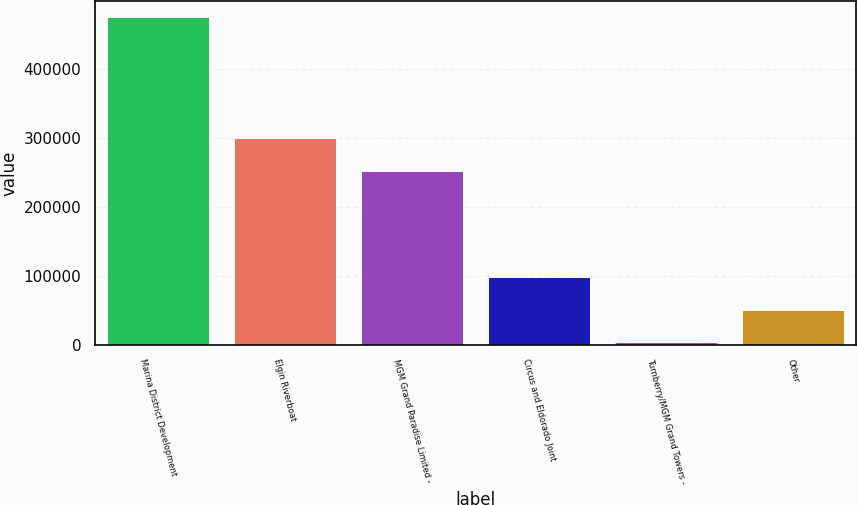Convert chart to OTSL. <chart><loc_0><loc_0><loc_500><loc_500><bar_chart><fcel>Marina District Development<fcel>Elgin Riverboat<fcel>MGM Grand Paradise Limited -<fcel>Circus and Eldorado Joint<fcel>Turnberry/MGM Grand Towers -<fcel>Other<nl><fcel>474171<fcel>299146<fcel>252060<fcel>97481.4<fcel>3309<fcel>50395.2<nl></chart> 